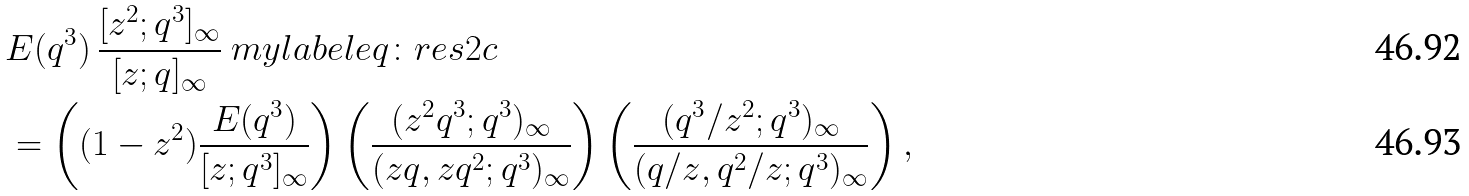Convert formula to latex. <formula><loc_0><loc_0><loc_500><loc_500>& E ( q ^ { 3 } ) \, \frac { [ z ^ { 2 } ; q ^ { 3 } ] _ { \infty } } { [ z ; q ] _ { \infty } } \ m y l a b e l { e q \colon r e s 2 c } \\ & = \left ( ( 1 - z ^ { 2 } ) \frac { E ( q ^ { 3 } ) } { [ z ; q ^ { 3 } ] _ { \infty } } \right ) \left ( \frac { ( z ^ { 2 } q ^ { 3 } ; q ^ { 3 } ) _ { \infty } } { ( z q , z q ^ { 2 } ; q ^ { 3 } ) _ { \infty } } \right ) \left ( \frac { ( q ^ { 3 } / z ^ { 2 } ; q ^ { 3 } ) _ { \infty } } { ( q / z , q ^ { 2 } / z ; q ^ { 3 } ) _ { \infty } } \right ) ,</formula> 